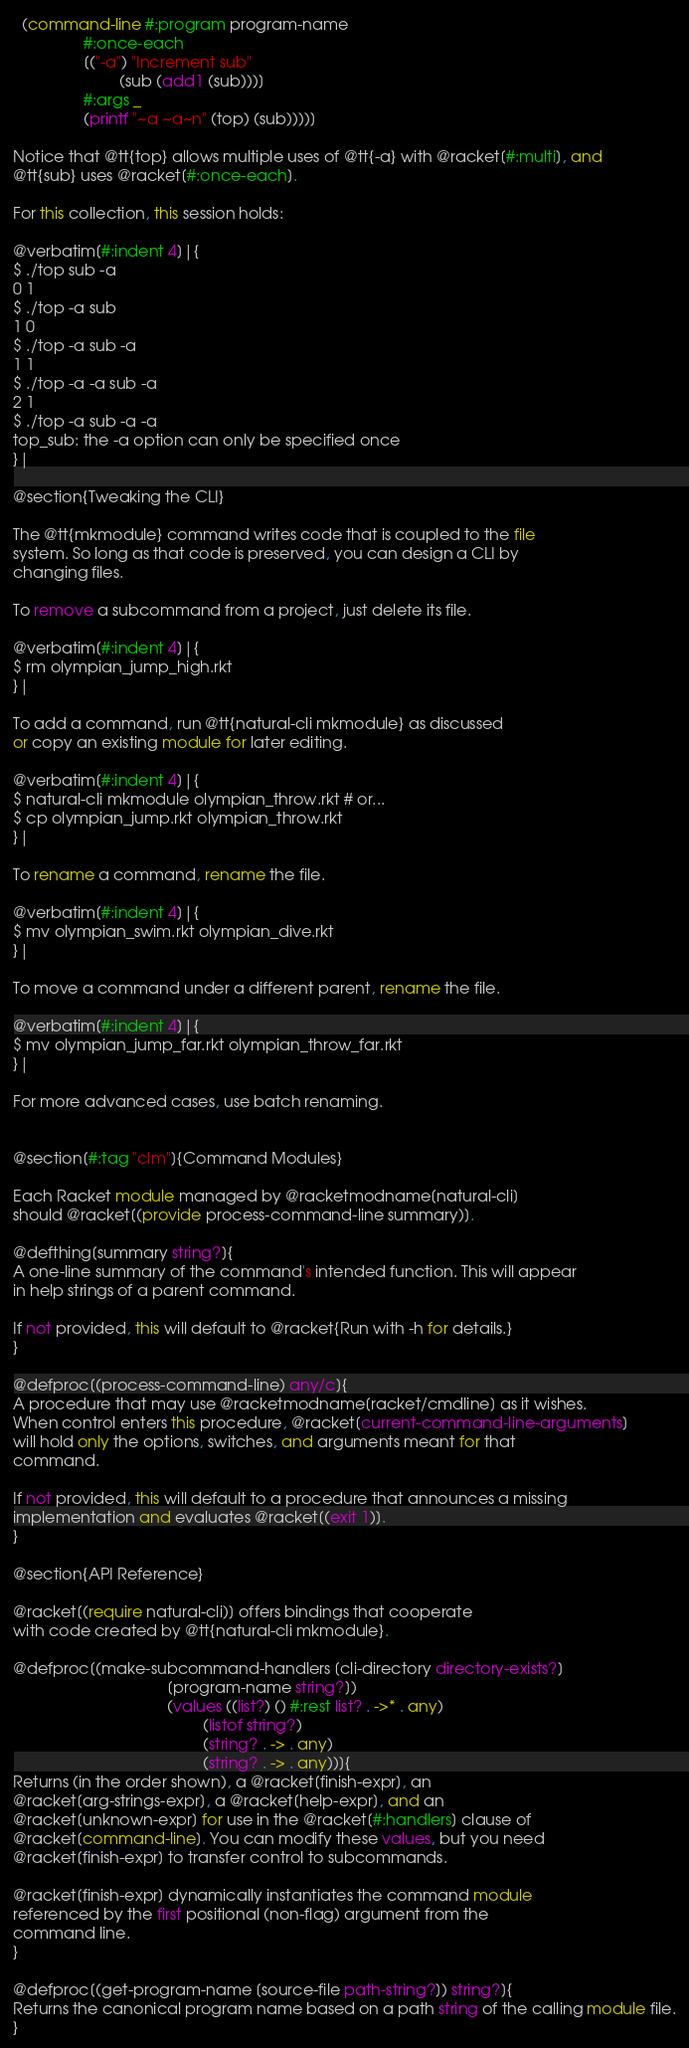<code> <loc_0><loc_0><loc_500><loc_500><_Racket_>  (command-line #:program program-name
                #:once-each
                [("-a") "Increment sub"
                        (sub (add1 (sub)))]
                #:args _
                (printf "~a ~a~n" (top) (sub))))]

Notice that @tt{top} allows multiple uses of @tt{-a} with @racket[#:multi], and
@tt{sub} uses @racket[#:once-each].

For this collection, this session holds:

@verbatim[#:indent 4]|{
$ ./top sub -a
0 1
$ ./top -a sub
1 0
$ ./top -a sub -a
1 1
$ ./top -a -a sub -a
2 1
$ ./top -a sub -a -a
top_sub: the -a option can only be specified once
}|

@section{Tweaking the CLI}

The @tt{mkmodule} command writes code that is coupled to the file
system. So long as that code is preserved, you can design a CLI by
changing files.

To remove a subcommand from a project, just delete its file.

@verbatim[#:indent 4]|{
$ rm olympian_jump_high.rkt
}|

To add a command, run @tt{natural-cli mkmodule} as discussed
or copy an existing module for later editing.

@verbatim[#:indent 4]|{
$ natural-cli mkmodule olympian_throw.rkt # or...
$ cp olympian_jump.rkt olympian_throw.rkt
}|

To rename a command, rename the file.

@verbatim[#:indent 4]|{
$ mv olympian_swim.rkt olympian_dive.rkt
}|

To move a command under a different parent, rename the file.

@verbatim[#:indent 4]|{
$ mv olympian_jump_far.rkt olympian_throw_far.rkt
}|

For more advanced cases, use batch renaming.


@section[#:tag "clm"]{Command Modules}

Each Racket module managed by @racketmodname[natural-cli]
should @racket[(provide process-command-line summary)].

@defthing[summary string?]{
A one-line summary of the command's intended function. This will appear
in help strings of a parent command.

If not provided, this will default to @racket{Run with -h for details.}
}

@defproc[(process-command-line) any/c]{
A procedure that may use @racketmodname[racket/cmdline] as it wishes.
When control enters this procedure, @racket[current-command-line-arguments]
will hold only the options, switches, and arguments meant for that
command.

If not provided, this will default to a procedure that announces a missing
implementation and evaluates @racket[(exit 1)].
}

@section{API Reference}

@racket[(require natural-cli)] offers bindings that cooperate
with code created by @tt{natural-cli mkmodule}.

@defproc[(make-subcommand-handlers [cli-directory directory-exists?]
                                   [program-name string?])
                                   (values ((list?) () #:rest list? . ->* . any)
                                           (listof string?)
                                           (string? . -> . any)
                                           (string? . -> . any))]{
Returns (in the order shown), a @racket[finish-expr], an
@racket[arg-strings-expr], a @racket[help-expr], and an
@racket[unknown-expr] for use in the @racket[#:handlers] clause of
@racket[command-line]. You can modify these values, but you need
@racket[finish-expr] to transfer control to subcommands.

@racket[finish-expr] dynamically instantiates the command module
referenced by the first positional (non-flag) argument from the
command line.
}

@defproc[(get-program-name [source-file path-string?]) string?]{
Returns the canonical program name based on a path string of the calling module file.
}
</code> 